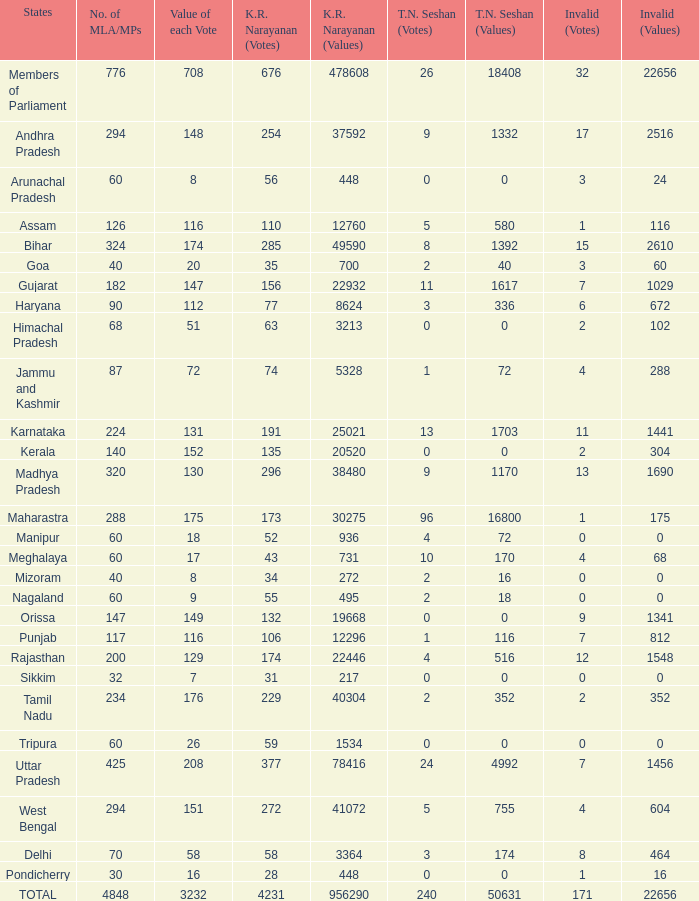How many votes (936) did kr narayanan get for values? 52.0. 